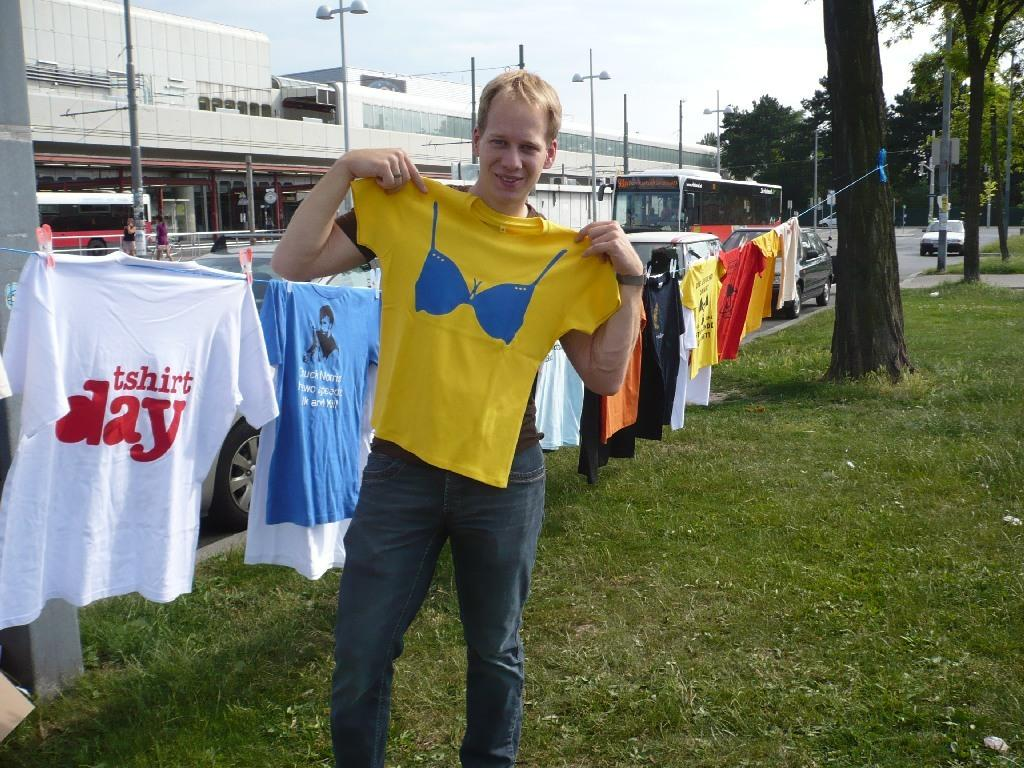<image>
Relay a brief, clear account of the picture shown. A collection of t-shirts hang on a line, one of them reading t-shirt day. 